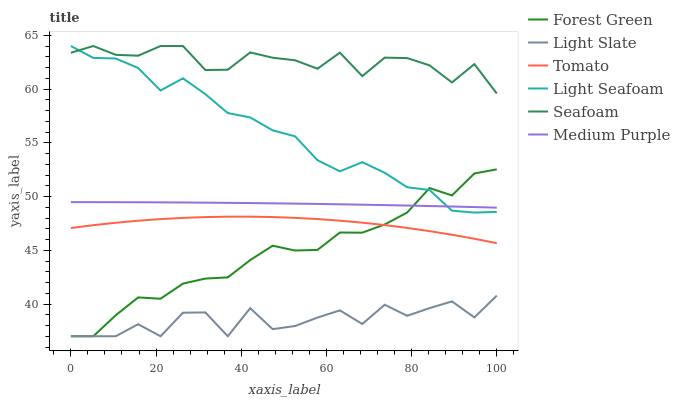Does Light Slate have the minimum area under the curve?
Answer yes or no. Yes. Does Seafoam have the maximum area under the curve?
Answer yes or no. Yes. Does Seafoam have the minimum area under the curve?
Answer yes or no. No. Does Light Slate have the maximum area under the curve?
Answer yes or no. No. Is Medium Purple the smoothest?
Answer yes or no. Yes. Is Light Slate the roughest?
Answer yes or no. Yes. Is Seafoam the smoothest?
Answer yes or no. No. Is Seafoam the roughest?
Answer yes or no. No. Does Light Slate have the lowest value?
Answer yes or no. Yes. Does Seafoam have the lowest value?
Answer yes or no. No. Does Light Seafoam have the highest value?
Answer yes or no. Yes. Does Light Slate have the highest value?
Answer yes or no. No. Is Light Slate less than Light Seafoam?
Answer yes or no. Yes. Is Medium Purple greater than Light Slate?
Answer yes or no. Yes. Does Light Seafoam intersect Medium Purple?
Answer yes or no. Yes. Is Light Seafoam less than Medium Purple?
Answer yes or no. No. Is Light Seafoam greater than Medium Purple?
Answer yes or no. No. Does Light Slate intersect Light Seafoam?
Answer yes or no. No. 